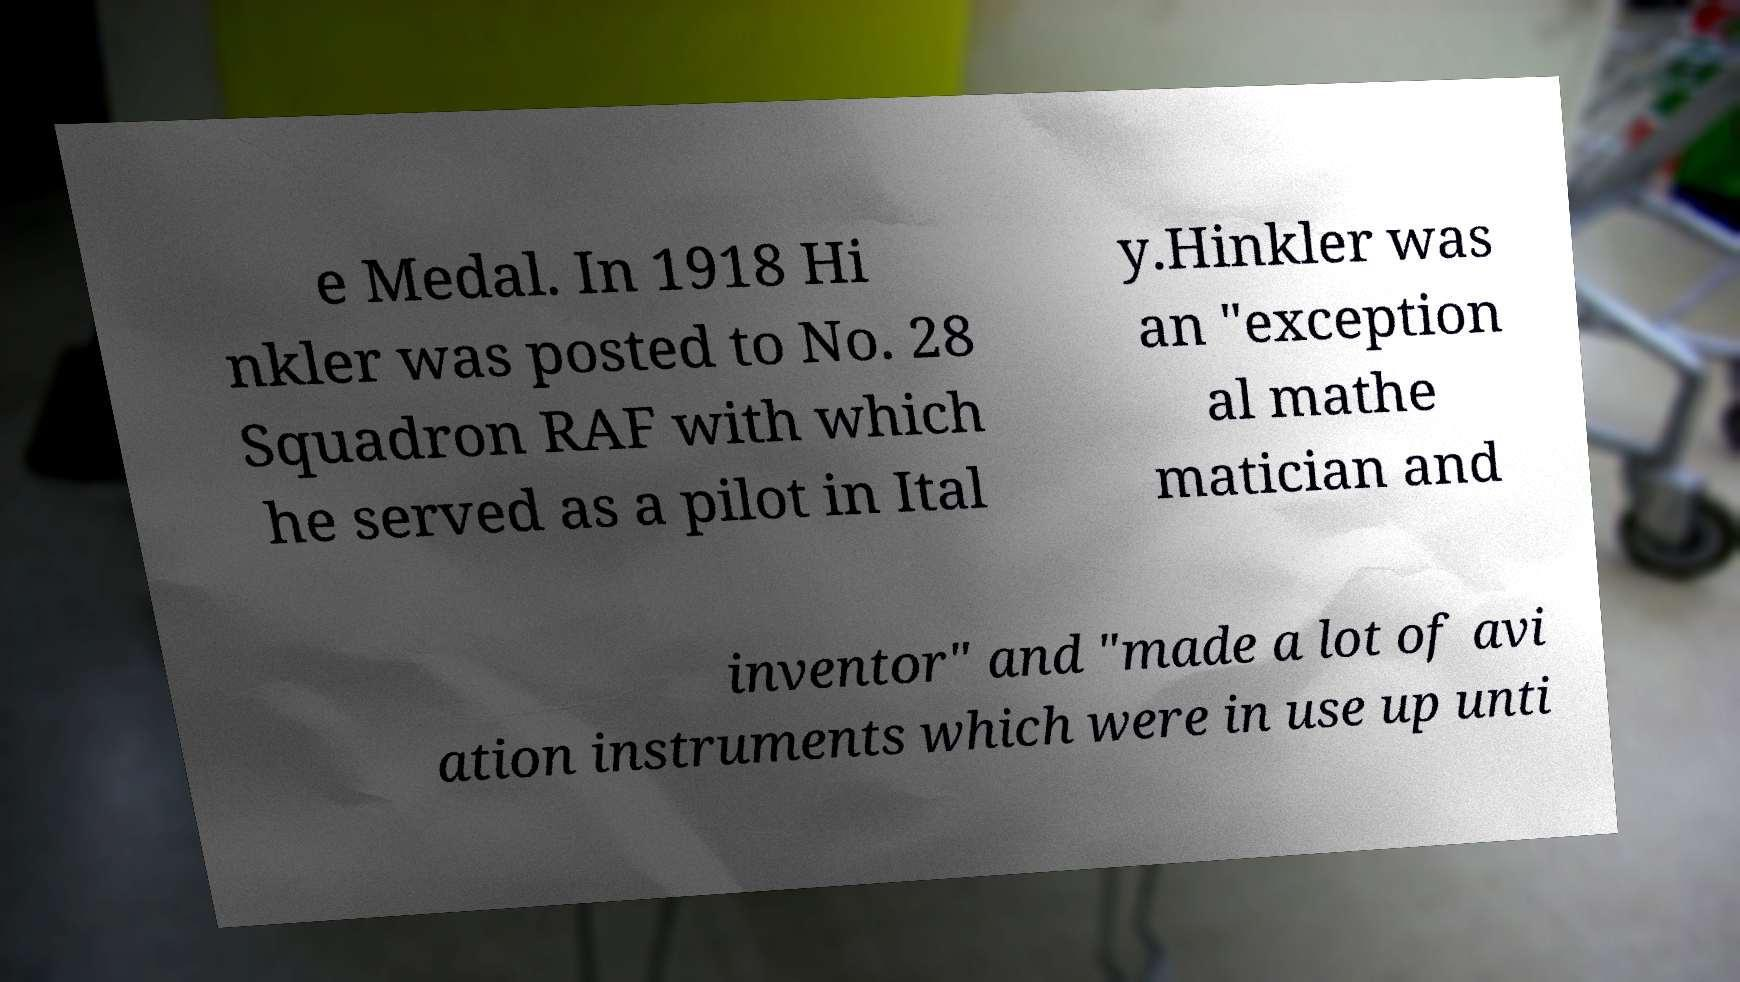Can you accurately transcribe the text from the provided image for me? e Medal. In 1918 Hi nkler was posted to No. 28 Squadron RAF with which he served as a pilot in Ital y.Hinkler was an "exception al mathe matician and inventor" and "made a lot of avi ation instruments which were in use up unti 